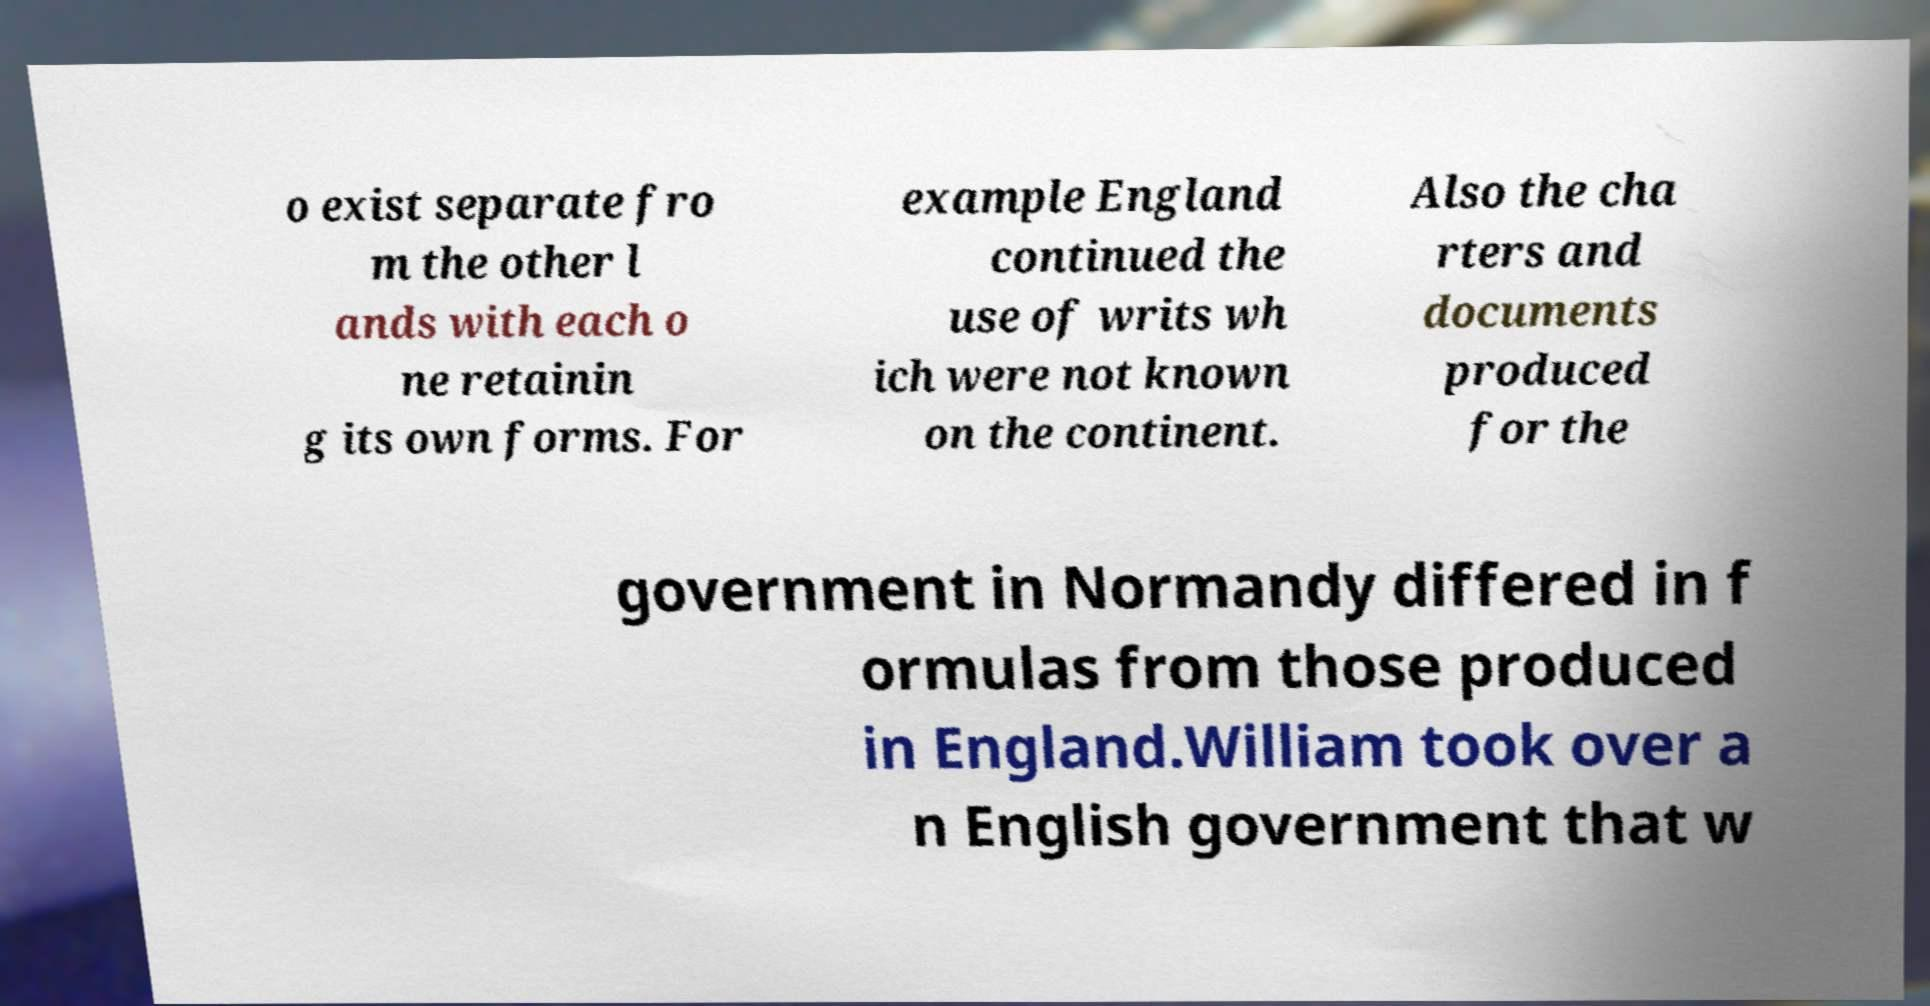Can you read and provide the text displayed in the image?This photo seems to have some interesting text. Can you extract and type it out for me? o exist separate fro m the other l ands with each o ne retainin g its own forms. For example England continued the use of writs wh ich were not known on the continent. Also the cha rters and documents produced for the government in Normandy differed in f ormulas from those produced in England.William took over a n English government that w 